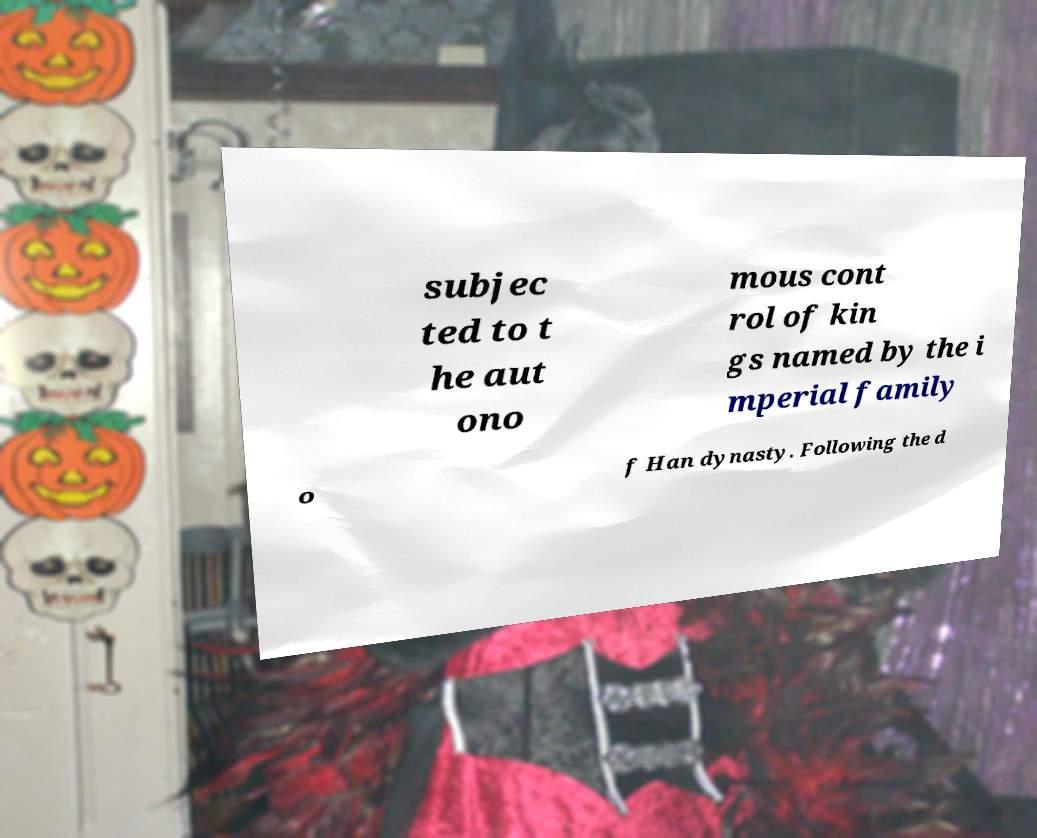I need the written content from this picture converted into text. Can you do that? subjec ted to t he aut ono mous cont rol of kin gs named by the i mperial family o f Han dynasty. Following the d 